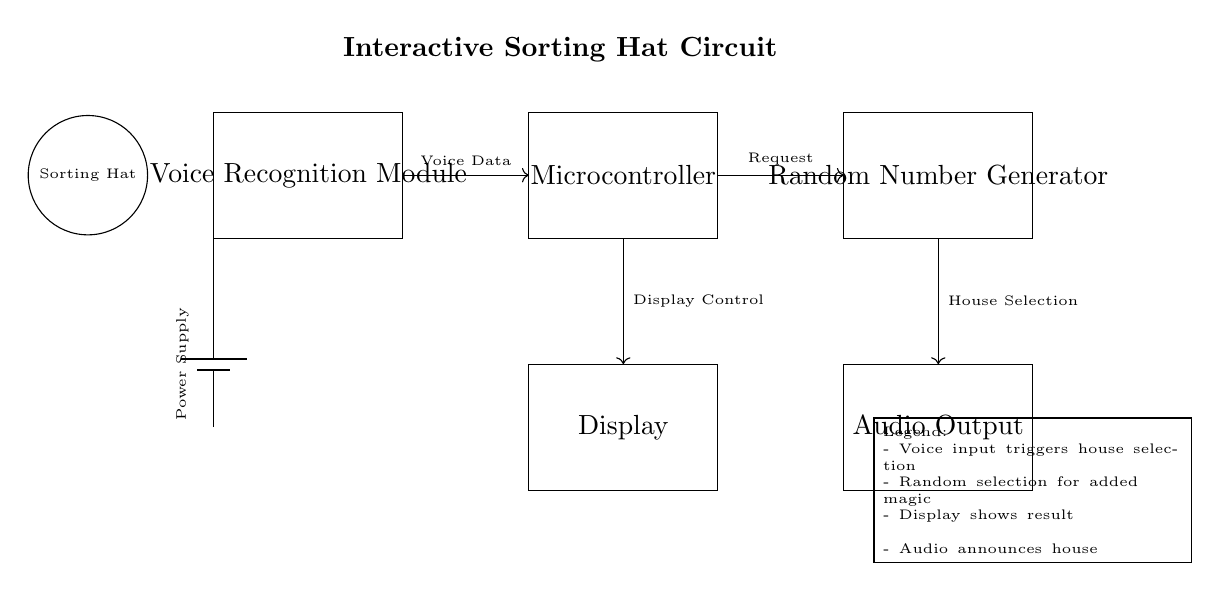What is the main function of the Voice Recognition Module? The Voice Recognition Module's main function is to receive and process voice input from users, enabling the system to identify their requests for house sorting.
Answer: house sorting What does the audio output deliver? The audio output component is responsible for announcing the selected house to the user after the sorting process is completed.
Answer: selected house Which component generates the random selection for sorting? The Random Number Generator is the component that produces a random number, which is then used to select one of the houses by the circuit.
Answer: Random Number Generator What triggers the house selection process? The house selection process is triggered by the voice data received from the Voice Recognition Module, which indicates the user's request to sort into a house.
Answer: Voice Data How many main components are in the circuit? There are five main components in this circuit: the Voice Recognition Module, Microcontroller, Random Number Generator, Display, and Audio Output.
Answer: five What role does the Microcontroller play in this circuit? The Microcontroller acts as the central processing unit that manages the flow of data between the components, including receiving the voice input, directing the random selection, and controlling the display output.
Answer: central processing unit What allows for the display to show the sorting result? The display control from the Microcontroller allows for the Display component to show the result of the house selection process, providing feedback to the user.
Answer: Display Control 